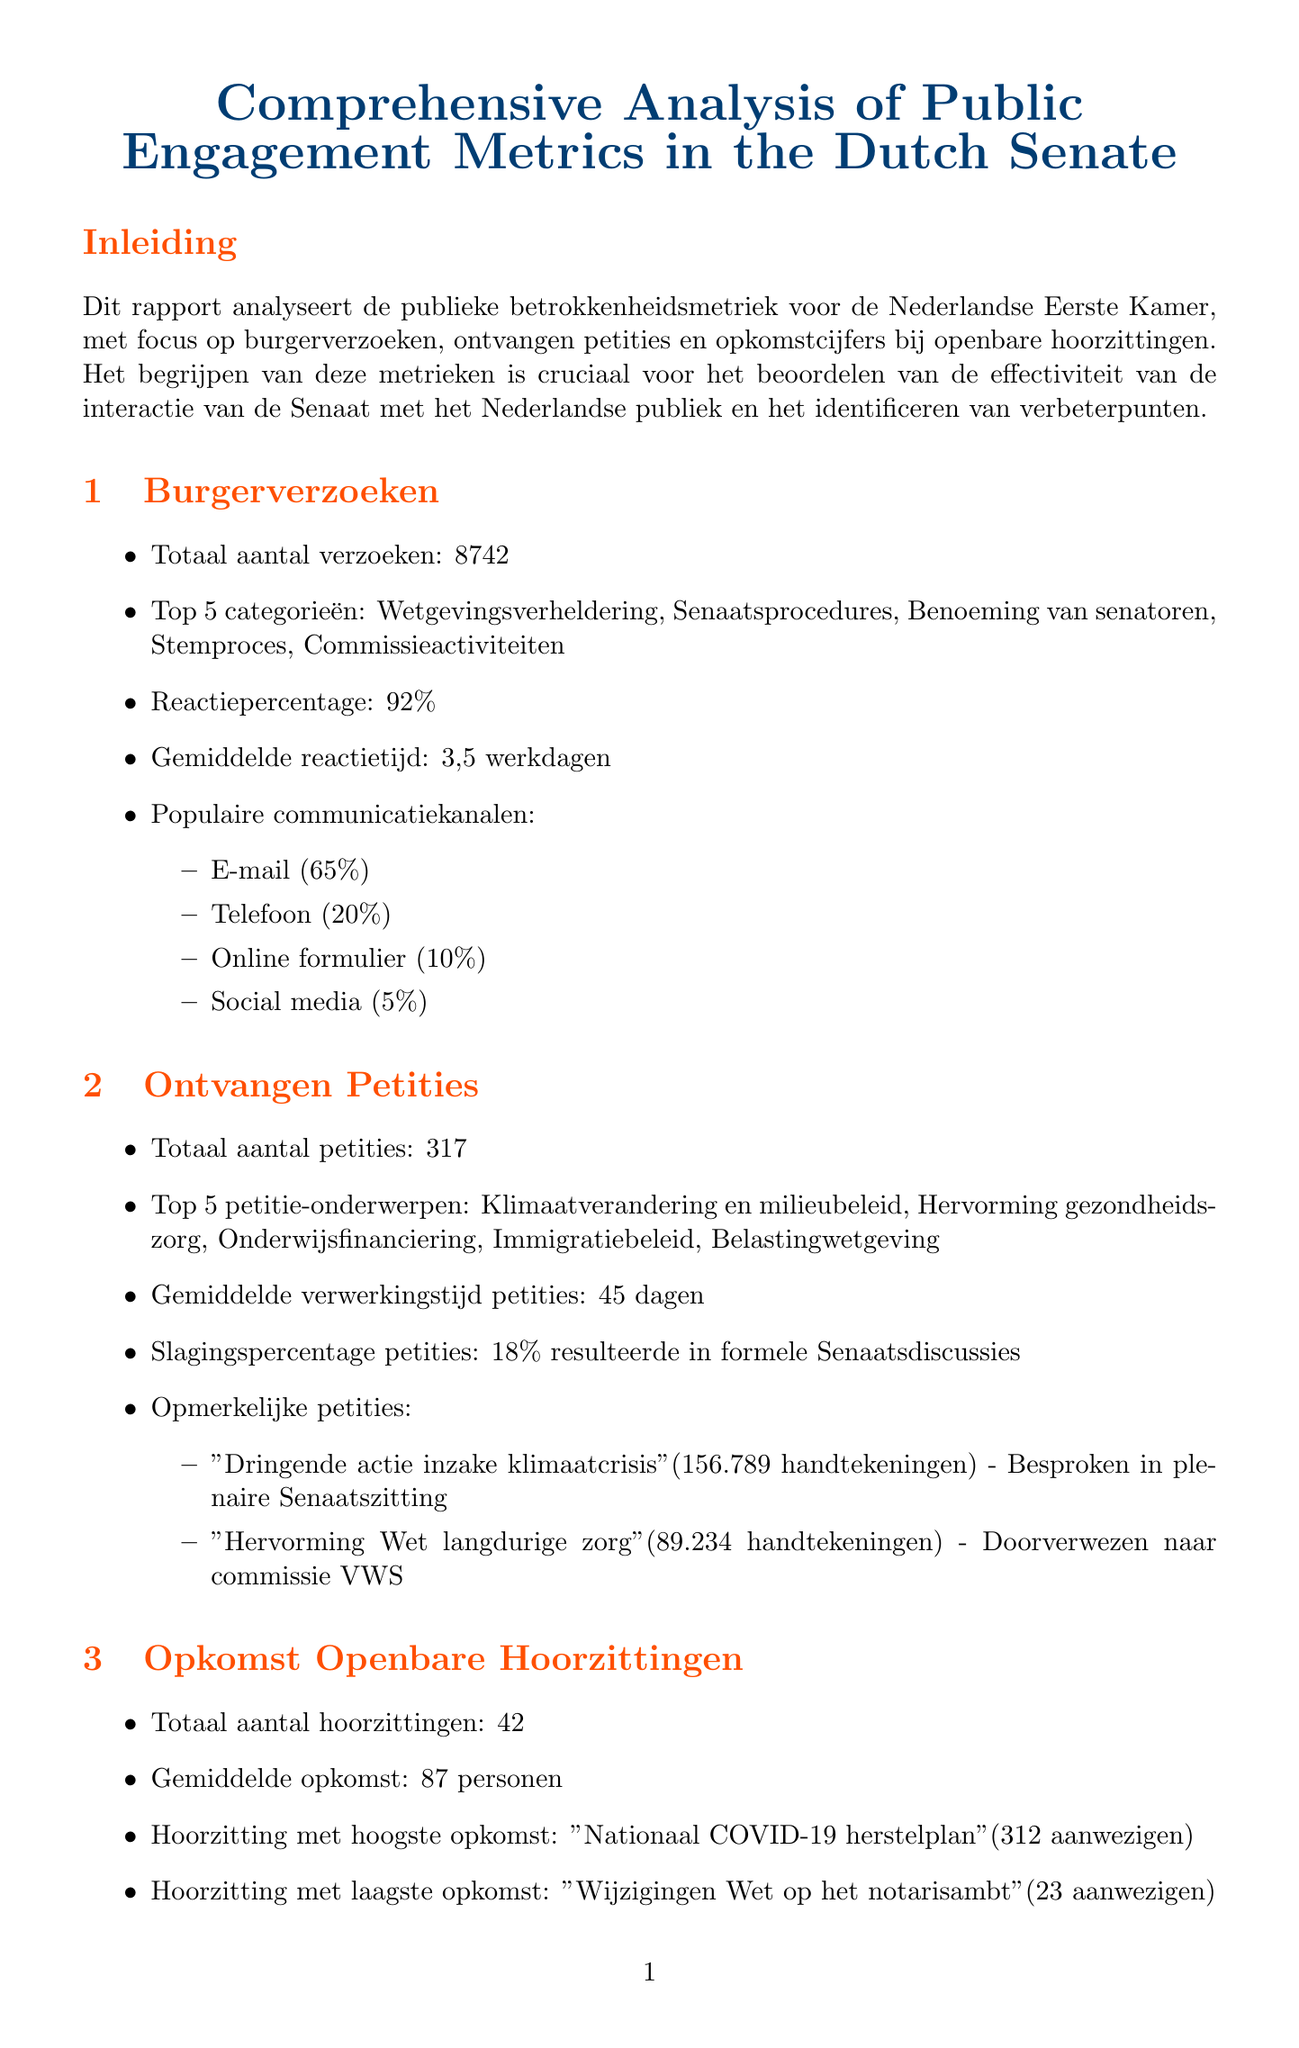what is the total number of citizen inquiries? The total number of citizen inquiries is directly stated in the document under the citizen inquiries section.
Answer: 8742 what is the average response time for citizen inquiries? The average response time is mentioned as "3.5 working days" in the citizen inquiries section.
Answer: 3.5 working days what percentage of petitions resulted in formal Senate discussions? The petition success rate is provided in the petitions received section.
Answer: 18% what topic had the highest attendance at a public hearing? The highest attended hearing topic is mentioned in the public hearing attendance section.
Answer: National COVID-19 Recovery Plan by what percentage did in-person attendance decrease compared to the previous year? The attendance trends specifically outline the decrease in in-person attendance compared to last year.
Answer: 15% how many notable petitions were discussed in the report? The notable petitions section lists the number of notable petitions included.
Answer: 2 which communication channel was most popular for citizen inquiries? The popular communication channels section shows the most used channel for citizen inquiries.
Answer: Email (65%) what was the total number of public hearings held? The document provides the total number of public hearings under the public hearing attendance section.
Answer: 42 what is one recommendation mentioned for improving public engagement? The recommendations section offers several suggestions for enhancing public engagement in the Senate.
Answer: Implement a dedicated digital platform for citizen inquiries to improve response times 